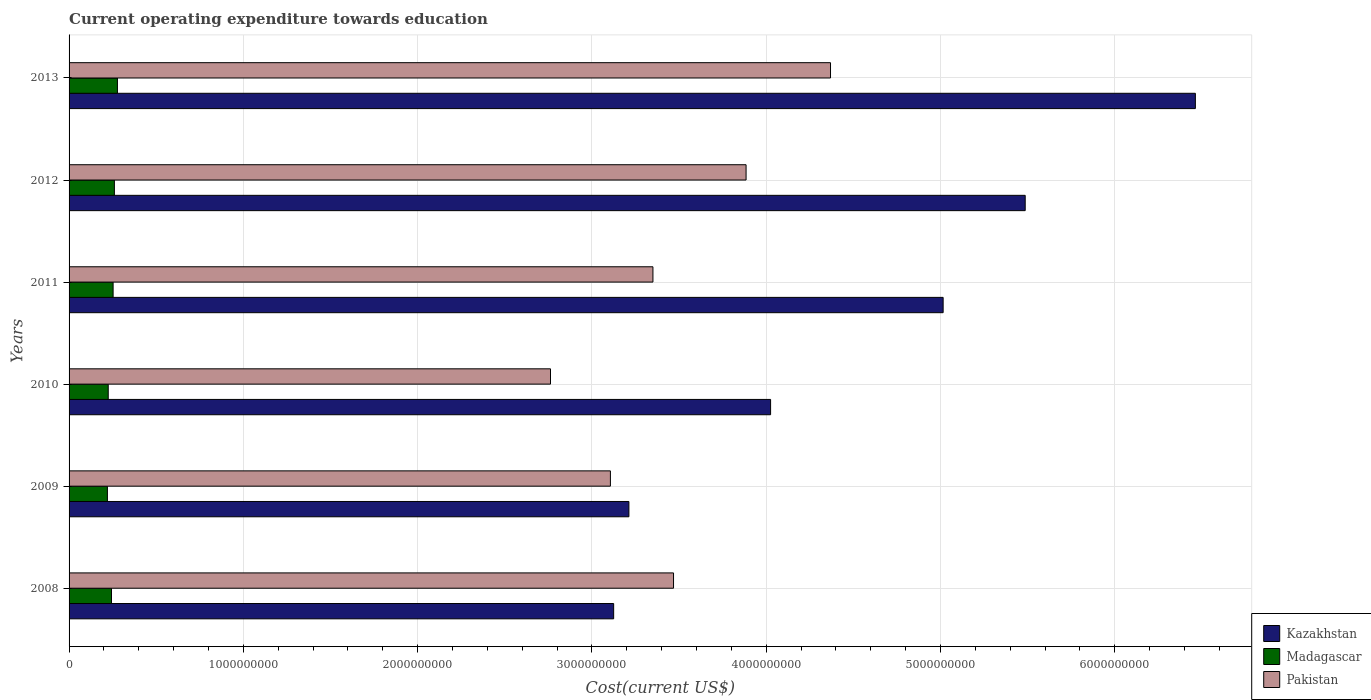How many different coloured bars are there?
Keep it short and to the point. 3. Are the number of bars per tick equal to the number of legend labels?
Make the answer very short. Yes. How many bars are there on the 6th tick from the top?
Ensure brevity in your answer.  3. How many bars are there on the 6th tick from the bottom?
Your response must be concise. 3. What is the label of the 5th group of bars from the top?
Make the answer very short. 2009. In how many cases, is the number of bars for a given year not equal to the number of legend labels?
Provide a succinct answer. 0. What is the expenditure towards education in Madagascar in 2011?
Your answer should be compact. 2.53e+08. Across all years, what is the maximum expenditure towards education in Madagascar?
Give a very brief answer. 2.78e+08. Across all years, what is the minimum expenditure towards education in Pakistan?
Keep it short and to the point. 2.76e+09. What is the total expenditure towards education in Madagascar in the graph?
Provide a succinct answer. 1.48e+09. What is the difference between the expenditure towards education in Kazakhstan in 2008 and that in 2010?
Make the answer very short. -9.00e+08. What is the difference between the expenditure towards education in Madagascar in 2011 and the expenditure towards education in Kazakhstan in 2013?
Provide a succinct answer. -6.21e+09. What is the average expenditure towards education in Kazakhstan per year?
Ensure brevity in your answer.  4.55e+09. In the year 2012, what is the difference between the expenditure towards education in Madagascar and expenditure towards education in Pakistan?
Ensure brevity in your answer.  -3.62e+09. In how many years, is the expenditure towards education in Pakistan greater than 1200000000 US$?
Give a very brief answer. 6. What is the ratio of the expenditure towards education in Kazakhstan in 2008 to that in 2011?
Offer a terse response. 0.62. Is the difference between the expenditure towards education in Madagascar in 2008 and 2013 greater than the difference between the expenditure towards education in Pakistan in 2008 and 2013?
Your response must be concise. Yes. What is the difference between the highest and the second highest expenditure towards education in Kazakhstan?
Keep it short and to the point. 9.76e+08. What is the difference between the highest and the lowest expenditure towards education in Kazakhstan?
Make the answer very short. 3.34e+09. In how many years, is the expenditure towards education in Pakistan greater than the average expenditure towards education in Pakistan taken over all years?
Provide a short and direct response. 2. Is the sum of the expenditure towards education in Kazakhstan in 2011 and 2012 greater than the maximum expenditure towards education in Pakistan across all years?
Make the answer very short. Yes. What does the 2nd bar from the bottom in 2010 represents?
Provide a succinct answer. Madagascar. How many bars are there?
Offer a very short reply. 18. How many years are there in the graph?
Your answer should be compact. 6. What is the difference between two consecutive major ticks on the X-axis?
Provide a succinct answer. 1.00e+09. Does the graph contain any zero values?
Give a very brief answer. No. Does the graph contain grids?
Your answer should be very brief. Yes. Where does the legend appear in the graph?
Give a very brief answer. Bottom right. How are the legend labels stacked?
Your answer should be compact. Vertical. What is the title of the graph?
Provide a short and direct response. Current operating expenditure towards education. What is the label or title of the X-axis?
Offer a terse response. Cost(current US$). What is the label or title of the Y-axis?
Make the answer very short. Years. What is the Cost(current US$) in Kazakhstan in 2008?
Your answer should be compact. 3.12e+09. What is the Cost(current US$) in Madagascar in 2008?
Your answer should be very brief. 2.43e+08. What is the Cost(current US$) of Pakistan in 2008?
Your answer should be compact. 3.47e+09. What is the Cost(current US$) in Kazakhstan in 2009?
Your answer should be very brief. 3.21e+09. What is the Cost(current US$) in Madagascar in 2009?
Your response must be concise. 2.20e+08. What is the Cost(current US$) in Pakistan in 2009?
Ensure brevity in your answer.  3.11e+09. What is the Cost(current US$) of Kazakhstan in 2010?
Keep it short and to the point. 4.03e+09. What is the Cost(current US$) in Madagascar in 2010?
Ensure brevity in your answer.  2.25e+08. What is the Cost(current US$) in Pakistan in 2010?
Provide a succinct answer. 2.76e+09. What is the Cost(current US$) in Kazakhstan in 2011?
Your answer should be compact. 5.02e+09. What is the Cost(current US$) in Madagascar in 2011?
Make the answer very short. 2.53e+08. What is the Cost(current US$) in Pakistan in 2011?
Ensure brevity in your answer.  3.35e+09. What is the Cost(current US$) of Kazakhstan in 2012?
Ensure brevity in your answer.  5.49e+09. What is the Cost(current US$) in Madagascar in 2012?
Offer a very short reply. 2.60e+08. What is the Cost(current US$) of Pakistan in 2012?
Offer a very short reply. 3.88e+09. What is the Cost(current US$) of Kazakhstan in 2013?
Provide a succinct answer. 6.46e+09. What is the Cost(current US$) of Madagascar in 2013?
Keep it short and to the point. 2.78e+08. What is the Cost(current US$) in Pakistan in 2013?
Your answer should be compact. 4.37e+09. Across all years, what is the maximum Cost(current US$) in Kazakhstan?
Offer a terse response. 6.46e+09. Across all years, what is the maximum Cost(current US$) in Madagascar?
Ensure brevity in your answer.  2.78e+08. Across all years, what is the maximum Cost(current US$) in Pakistan?
Your answer should be very brief. 4.37e+09. Across all years, what is the minimum Cost(current US$) in Kazakhstan?
Give a very brief answer. 3.12e+09. Across all years, what is the minimum Cost(current US$) of Madagascar?
Offer a very short reply. 2.20e+08. Across all years, what is the minimum Cost(current US$) of Pakistan?
Your answer should be compact. 2.76e+09. What is the total Cost(current US$) in Kazakhstan in the graph?
Ensure brevity in your answer.  2.73e+1. What is the total Cost(current US$) in Madagascar in the graph?
Your answer should be very brief. 1.48e+09. What is the total Cost(current US$) in Pakistan in the graph?
Your answer should be compact. 2.09e+1. What is the difference between the Cost(current US$) of Kazakhstan in 2008 and that in 2009?
Ensure brevity in your answer.  -8.75e+07. What is the difference between the Cost(current US$) in Madagascar in 2008 and that in 2009?
Your response must be concise. 2.35e+07. What is the difference between the Cost(current US$) of Pakistan in 2008 and that in 2009?
Make the answer very short. 3.62e+08. What is the difference between the Cost(current US$) of Kazakhstan in 2008 and that in 2010?
Provide a short and direct response. -9.00e+08. What is the difference between the Cost(current US$) in Madagascar in 2008 and that in 2010?
Ensure brevity in your answer.  1.87e+07. What is the difference between the Cost(current US$) of Pakistan in 2008 and that in 2010?
Provide a succinct answer. 7.06e+08. What is the difference between the Cost(current US$) of Kazakhstan in 2008 and that in 2011?
Keep it short and to the point. -1.89e+09. What is the difference between the Cost(current US$) in Madagascar in 2008 and that in 2011?
Provide a short and direct response. -9.28e+06. What is the difference between the Cost(current US$) of Pakistan in 2008 and that in 2011?
Provide a succinct answer. 1.18e+08. What is the difference between the Cost(current US$) of Kazakhstan in 2008 and that in 2012?
Give a very brief answer. -2.36e+09. What is the difference between the Cost(current US$) in Madagascar in 2008 and that in 2012?
Your answer should be very brief. -1.66e+07. What is the difference between the Cost(current US$) in Pakistan in 2008 and that in 2012?
Your answer should be very brief. -4.16e+08. What is the difference between the Cost(current US$) in Kazakhstan in 2008 and that in 2013?
Provide a short and direct response. -3.34e+09. What is the difference between the Cost(current US$) of Madagascar in 2008 and that in 2013?
Keep it short and to the point. -3.41e+07. What is the difference between the Cost(current US$) in Pakistan in 2008 and that in 2013?
Ensure brevity in your answer.  -9.01e+08. What is the difference between the Cost(current US$) in Kazakhstan in 2009 and that in 2010?
Ensure brevity in your answer.  -8.13e+08. What is the difference between the Cost(current US$) in Madagascar in 2009 and that in 2010?
Provide a succinct answer. -4.79e+06. What is the difference between the Cost(current US$) in Pakistan in 2009 and that in 2010?
Provide a succinct answer. 3.44e+08. What is the difference between the Cost(current US$) of Kazakhstan in 2009 and that in 2011?
Ensure brevity in your answer.  -1.80e+09. What is the difference between the Cost(current US$) of Madagascar in 2009 and that in 2011?
Provide a succinct answer. -3.28e+07. What is the difference between the Cost(current US$) in Pakistan in 2009 and that in 2011?
Your answer should be compact. -2.44e+08. What is the difference between the Cost(current US$) in Kazakhstan in 2009 and that in 2012?
Your answer should be compact. -2.27e+09. What is the difference between the Cost(current US$) of Madagascar in 2009 and that in 2012?
Your answer should be very brief. -4.01e+07. What is the difference between the Cost(current US$) in Pakistan in 2009 and that in 2012?
Provide a succinct answer. -7.79e+08. What is the difference between the Cost(current US$) of Kazakhstan in 2009 and that in 2013?
Ensure brevity in your answer.  -3.25e+09. What is the difference between the Cost(current US$) in Madagascar in 2009 and that in 2013?
Your answer should be compact. -5.76e+07. What is the difference between the Cost(current US$) of Pakistan in 2009 and that in 2013?
Give a very brief answer. -1.26e+09. What is the difference between the Cost(current US$) of Kazakhstan in 2010 and that in 2011?
Provide a succinct answer. -9.90e+08. What is the difference between the Cost(current US$) in Madagascar in 2010 and that in 2011?
Offer a very short reply. -2.80e+07. What is the difference between the Cost(current US$) in Pakistan in 2010 and that in 2011?
Give a very brief answer. -5.88e+08. What is the difference between the Cost(current US$) in Kazakhstan in 2010 and that in 2012?
Your answer should be very brief. -1.46e+09. What is the difference between the Cost(current US$) in Madagascar in 2010 and that in 2012?
Keep it short and to the point. -3.53e+07. What is the difference between the Cost(current US$) of Pakistan in 2010 and that in 2012?
Offer a terse response. -1.12e+09. What is the difference between the Cost(current US$) in Kazakhstan in 2010 and that in 2013?
Keep it short and to the point. -2.44e+09. What is the difference between the Cost(current US$) of Madagascar in 2010 and that in 2013?
Offer a very short reply. -5.28e+07. What is the difference between the Cost(current US$) in Pakistan in 2010 and that in 2013?
Keep it short and to the point. -1.61e+09. What is the difference between the Cost(current US$) in Kazakhstan in 2011 and that in 2012?
Your answer should be compact. -4.71e+08. What is the difference between the Cost(current US$) in Madagascar in 2011 and that in 2012?
Provide a succinct answer. -7.31e+06. What is the difference between the Cost(current US$) in Pakistan in 2011 and that in 2012?
Make the answer very short. -5.34e+08. What is the difference between the Cost(current US$) of Kazakhstan in 2011 and that in 2013?
Your answer should be compact. -1.45e+09. What is the difference between the Cost(current US$) in Madagascar in 2011 and that in 2013?
Give a very brief answer. -2.48e+07. What is the difference between the Cost(current US$) of Pakistan in 2011 and that in 2013?
Give a very brief answer. -1.02e+09. What is the difference between the Cost(current US$) in Kazakhstan in 2012 and that in 2013?
Ensure brevity in your answer.  -9.76e+08. What is the difference between the Cost(current US$) of Madagascar in 2012 and that in 2013?
Ensure brevity in your answer.  -1.75e+07. What is the difference between the Cost(current US$) of Pakistan in 2012 and that in 2013?
Your answer should be compact. -4.84e+08. What is the difference between the Cost(current US$) of Kazakhstan in 2008 and the Cost(current US$) of Madagascar in 2009?
Keep it short and to the point. 2.90e+09. What is the difference between the Cost(current US$) of Kazakhstan in 2008 and the Cost(current US$) of Pakistan in 2009?
Your answer should be compact. 1.87e+07. What is the difference between the Cost(current US$) of Madagascar in 2008 and the Cost(current US$) of Pakistan in 2009?
Make the answer very short. -2.86e+09. What is the difference between the Cost(current US$) in Kazakhstan in 2008 and the Cost(current US$) in Madagascar in 2010?
Offer a terse response. 2.90e+09. What is the difference between the Cost(current US$) in Kazakhstan in 2008 and the Cost(current US$) in Pakistan in 2010?
Offer a terse response. 3.62e+08. What is the difference between the Cost(current US$) in Madagascar in 2008 and the Cost(current US$) in Pakistan in 2010?
Make the answer very short. -2.52e+09. What is the difference between the Cost(current US$) of Kazakhstan in 2008 and the Cost(current US$) of Madagascar in 2011?
Keep it short and to the point. 2.87e+09. What is the difference between the Cost(current US$) in Kazakhstan in 2008 and the Cost(current US$) in Pakistan in 2011?
Ensure brevity in your answer.  -2.25e+08. What is the difference between the Cost(current US$) of Madagascar in 2008 and the Cost(current US$) of Pakistan in 2011?
Provide a short and direct response. -3.11e+09. What is the difference between the Cost(current US$) in Kazakhstan in 2008 and the Cost(current US$) in Madagascar in 2012?
Offer a terse response. 2.86e+09. What is the difference between the Cost(current US$) in Kazakhstan in 2008 and the Cost(current US$) in Pakistan in 2012?
Provide a short and direct response. -7.60e+08. What is the difference between the Cost(current US$) of Madagascar in 2008 and the Cost(current US$) of Pakistan in 2012?
Provide a short and direct response. -3.64e+09. What is the difference between the Cost(current US$) in Kazakhstan in 2008 and the Cost(current US$) in Madagascar in 2013?
Give a very brief answer. 2.85e+09. What is the difference between the Cost(current US$) in Kazakhstan in 2008 and the Cost(current US$) in Pakistan in 2013?
Your answer should be compact. -1.24e+09. What is the difference between the Cost(current US$) of Madagascar in 2008 and the Cost(current US$) of Pakistan in 2013?
Your answer should be very brief. -4.13e+09. What is the difference between the Cost(current US$) in Kazakhstan in 2009 and the Cost(current US$) in Madagascar in 2010?
Give a very brief answer. 2.99e+09. What is the difference between the Cost(current US$) of Kazakhstan in 2009 and the Cost(current US$) of Pakistan in 2010?
Offer a very short reply. 4.50e+08. What is the difference between the Cost(current US$) in Madagascar in 2009 and the Cost(current US$) in Pakistan in 2010?
Offer a very short reply. -2.54e+09. What is the difference between the Cost(current US$) of Kazakhstan in 2009 and the Cost(current US$) of Madagascar in 2011?
Keep it short and to the point. 2.96e+09. What is the difference between the Cost(current US$) of Kazakhstan in 2009 and the Cost(current US$) of Pakistan in 2011?
Your answer should be very brief. -1.38e+08. What is the difference between the Cost(current US$) of Madagascar in 2009 and the Cost(current US$) of Pakistan in 2011?
Your response must be concise. -3.13e+09. What is the difference between the Cost(current US$) of Kazakhstan in 2009 and the Cost(current US$) of Madagascar in 2012?
Provide a succinct answer. 2.95e+09. What is the difference between the Cost(current US$) in Kazakhstan in 2009 and the Cost(current US$) in Pakistan in 2012?
Provide a short and direct response. -6.72e+08. What is the difference between the Cost(current US$) in Madagascar in 2009 and the Cost(current US$) in Pakistan in 2012?
Offer a terse response. -3.66e+09. What is the difference between the Cost(current US$) in Kazakhstan in 2009 and the Cost(current US$) in Madagascar in 2013?
Offer a very short reply. 2.93e+09. What is the difference between the Cost(current US$) of Kazakhstan in 2009 and the Cost(current US$) of Pakistan in 2013?
Keep it short and to the point. -1.16e+09. What is the difference between the Cost(current US$) of Madagascar in 2009 and the Cost(current US$) of Pakistan in 2013?
Offer a terse response. -4.15e+09. What is the difference between the Cost(current US$) in Kazakhstan in 2010 and the Cost(current US$) in Madagascar in 2011?
Offer a very short reply. 3.77e+09. What is the difference between the Cost(current US$) in Kazakhstan in 2010 and the Cost(current US$) in Pakistan in 2011?
Ensure brevity in your answer.  6.75e+08. What is the difference between the Cost(current US$) of Madagascar in 2010 and the Cost(current US$) of Pakistan in 2011?
Give a very brief answer. -3.13e+09. What is the difference between the Cost(current US$) in Kazakhstan in 2010 and the Cost(current US$) in Madagascar in 2012?
Keep it short and to the point. 3.77e+09. What is the difference between the Cost(current US$) in Kazakhstan in 2010 and the Cost(current US$) in Pakistan in 2012?
Offer a terse response. 1.41e+08. What is the difference between the Cost(current US$) in Madagascar in 2010 and the Cost(current US$) in Pakistan in 2012?
Ensure brevity in your answer.  -3.66e+09. What is the difference between the Cost(current US$) in Kazakhstan in 2010 and the Cost(current US$) in Madagascar in 2013?
Offer a terse response. 3.75e+09. What is the difference between the Cost(current US$) of Kazakhstan in 2010 and the Cost(current US$) of Pakistan in 2013?
Ensure brevity in your answer.  -3.44e+08. What is the difference between the Cost(current US$) in Madagascar in 2010 and the Cost(current US$) in Pakistan in 2013?
Make the answer very short. -4.14e+09. What is the difference between the Cost(current US$) of Kazakhstan in 2011 and the Cost(current US$) of Madagascar in 2012?
Provide a succinct answer. 4.76e+09. What is the difference between the Cost(current US$) of Kazakhstan in 2011 and the Cost(current US$) of Pakistan in 2012?
Your response must be concise. 1.13e+09. What is the difference between the Cost(current US$) of Madagascar in 2011 and the Cost(current US$) of Pakistan in 2012?
Make the answer very short. -3.63e+09. What is the difference between the Cost(current US$) in Kazakhstan in 2011 and the Cost(current US$) in Madagascar in 2013?
Offer a very short reply. 4.74e+09. What is the difference between the Cost(current US$) in Kazakhstan in 2011 and the Cost(current US$) in Pakistan in 2013?
Your answer should be compact. 6.46e+08. What is the difference between the Cost(current US$) in Madagascar in 2011 and the Cost(current US$) in Pakistan in 2013?
Offer a very short reply. -4.12e+09. What is the difference between the Cost(current US$) in Kazakhstan in 2012 and the Cost(current US$) in Madagascar in 2013?
Offer a terse response. 5.21e+09. What is the difference between the Cost(current US$) of Kazakhstan in 2012 and the Cost(current US$) of Pakistan in 2013?
Provide a succinct answer. 1.12e+09. What is the difference between the Cost(current US$) of Madagascar in 2012 and the Cost(current US$) of Pakistan in 2013?
Keep it short and to the point. -4.11e+09. What is the average Cost(current US$) of Kazakhstan per year?
Your response must be concise. 4.55e+09. What is the average Cost(current US$) in Madagascar per year?
Keep it short and to the point. 2.46e+08. What is the average Cost(current US$) in Pakistan per year?
Provide a short and direct response. 3.49e+09. In the year 2008, what is the difference between the Cost(current US$) in Kazakhstan and Cost(current US$) in Madagascar?
Provide a succinct answer. 2.88e+09. In the year 2008, what is the difference between the Cost(current US$) of Kazakhstan and Cost(current US$) of Pakistan?
Ensure brevity in your answer.  -3.43e+08. In the year 2008, what is the difference between the Cost(current US$) in Madagascar and Cost(current US$) in Pakistan?
Keep it short and to the point. -3.22e+09. In the year 2009, what is the difference between the Cost(current US$) of Kazakhstan and Cost(current US$) of Madagascar?
Ensure brevity in your answer.  2.99e+09. In the year 2009, what is the difference between the Cost(current US$) of Kazakhstan and Cost(current US$) of Pakistan?
Offer a very short reply. 1.06e+08. In the year 2009, what is the difference between the Cost(current US$) of Madagascar and Cost(current US$) of Pakistan?
Your answer should be very brief. -2.89e+09. In the year 2010, what is the difference between the Cost(current US$) in Kazakhstan and Cost(current US$) in Madagascar?
Your answer should be compact. 3.80e+09. In the year 2010, what is the difference between the Cost(current US$) in Kazakhstan and Cost(current US$) in Pakistan?
Make the answer very short. 1.26e+09. In the year 2010, what is the difference between the Cost(current US$) in Madagascar and Cost(current US$) in Pakistan?
Your answer should be very brief. -2.54e+09. In the year 2011, what is the difference between the Cost(current US$) of Kazakhstan and Cost(current US$) of Madagascar?
Provide a short and direct response. 4.76e+09. In the year 2011, what is the difference between the Cost(current US$) of Kazakhstan and Cost(current US$) of Pakistan?
Your response must be concise. 1.67e+09. In the year 2011, what is the difference between the Cost(current US$) in Madagascar and Cost(current US$) in Pakistan?
Offer a very short reply. -3.10e+09. In the year 2012, what is the difference between the Cost(current US$) in Kazakhstan and Cost(current US$) in Madagascar?
Your answer should be very brief. 5.23e+09. In the year 2012, what is the difference between the Cost(current US$) of Kazakhstan and Cost(current US$) of Pakistan?
Provide a succinct answer. 1.60e+09. In the year 2012, what is the difference between the Cost(current US$) of Madagascar and Cost(current US$) of Pakistan?
Give a very brief answer. -3.62e+09. In the year 2013, what is the difference between the Cost(current US$) in Kazakhstan and Cost(current US$) in Madagascar?
Your response must be concise. 6.19e+09. In the year 2013, what is the difference between the Cost(current US$) of Kazakhstan and Cost(current US$) of Pakistan?
Provide a short and direct response. 2.09e+09. In the year 2013, what is the difference between the Cost(current US$) in Madagascar and Cost(current US$) in Pakistan?
Your answer should be compact. -4.09e+09. What is the ratio of the Cost(current US$) of Kazakhstan in 2008 to that in 2009?
Keep it short and to the point. 0.97. What is the ratio of the Cost(current US$) of Madagascar in 2008 to that in 2009?
Keep it short and to the point. 1.11. What is the ratio of the Cost(current US$) of Pakistan in 2008 to that in 2009?
Give a very brief answer. 1.12. What is the ratio of the Cost(current US$) in Kazakhstan in 2008 to that in 2010?
Make the answer very short. 0.78. What is the ratio of the Cost(current US$) in Madagascar in 2008 to that in 2010?
Ensure brevity in your answer.  1.08. What is the ratio of the Cost(current US$) of Pakistan in 2008 to that in 2010?
Provide a short and direct response. 1.26. What is the ratio of the Cost(current US$) in Kazakhstan in 2008 to that in 2011?
Your response must be concise. 0.62. What is the ratio of the Cost(current US$) in Madagascar in 2008 to that in 2011?
Your answer should be compact. 0.96. What is the ratio of the Cost(current US$) in Pakistan in 2008 to that in 2011?
Give a very brief answer. 1.04. What is the ratio of the Cost(current US$) of Kazakhstan in 2008 to that in 2012?
Offer a very short reply. 0.57. What is the ratio of the Cost(current US$) of Madagascar in 2008 to that in 2012?
Your response must be concise. 0.94. What is the ratio of the Cost(current US$) in Pakistan in 2008 to that in 2012?
Keep it short and to the point. 0.89. What is the ratio of the Cost(current US$) of Kazakhstan in 2008 to that in 2013?
Your response must be concise. 0.48. What is the ratio of the Cost(current US$) in Madagascar in 2008 to that in 2013?
Offer a very short reply. 0.88. What is the ratio of the Cost(current US$) of Pakistan in 2008 to that in 2013?
Offer a very short reply. 0.79. What is the ratio of the Cost(current US$) in Kazakhstan in 2009 to that in 2010?
Give a very brief answer. 0.8. What is the ratio of the Cost(current US$) in Madagascar in 2009 to that in 2010?
Your answer should be compact. 0.98. What is the ratio of the Cost(current US$) in Pakistan in 2009 to that in 2010?
Your answer should be compact. 1.12. What is the ratio of the Cost(current US$) of Kazakhstan in 2009 to that in 2011?
Your answer should be compact. 0.64. What is the ratio of the Cost(current US$) in Madagascar in 2009 to that in 2011?
Give a very brief answer. 0.87. What is the ratio of the Cost(current US$) of Pakistan in 2009 to that in 2011?
Provide a short and direct response. 0.93. What is the ratio of the Cost(current US$) in Kazakhstan in 2009 to that in 2012?
Ensure brevity in your answer.  0.59. What is the ratio of the Cost(current US$) of Madagascar in 2009 to that in 2012?
Your answer should be very brief. 0.85. What is the ratio of the Cost(current US$) of Pakistan in 2009 to that in 2012?
Make the answer very short. 0.8. What is the ratio of the Cost(current US$) in Kazakhstan in 2009 to that in 2013?
Your answer should be very brief. 0.5. What is the ratio of the Cost(current US$) of Madagascar in 2009 to that in 2013?
Make the answer very short. 0.79. What is the ratio of the Cost(current US$) in Pakistan in 2009 to that in 2013?
Give a very brief answer. 0.71. What is the ratio of the Cost(current US$) in Kazakhstan in 2010 to that in 2011?
Ensure brevity in your answer.  0.8. What is the ratio of the Cost(current US$) of Madagascar in 2010 to that in 2011?
Offer a very short reply. 0.89. What is the ratio of the Cost(current US$) of Pakistan in 2010 to that in 2011?
Give a very brief answer. 0.82. What is the ratio of the Cost(current US$) of Kazakhstan in 2010 to that in 2012?
Give a very brief answer. 0.73. What is the ratio of the Cost(current US$) in Madagascar in 2010 to that in 2012?
Your answer should be compact. 0.86. What is the ratio of the Cost(current US$) of Pakistan in 2010 to that in 2012?
Your answer should be compact. 0.71. What is the ratio of the Cost(current US$) in Kazakhstan in 2010 to that in 2013?
Your response must be concise. 0.62. What is the ratio of the Cost(current US$) in Madagascar in 2010 to that in 2013?
Ensure brevity in your answer.  0.81. What is the ratio of the Cost(current US$) of Pakistan in 2010 to that in 2013?
Keep it short and to the point. 0.63. What is the ratio of the Cost(current US$) of Kazakhstan in 2011 to that in 2012?
Your answer should be compact. 0.91. What is the ratio of the Cost(current US$) of Madagascar in 2011 to that in 2012?
Your answer should be compact. 0.97. What is the ratio of the Cost(current US$) of Pakistan in 2011 to that in 2012?
Offer a terse response. 0.86. What is the ratio of the Cost(current US$) of Kazakhstan in 2011 to that in 2013?
Ensure brevity in your answer.  0.78. What is the ratio of the Cost(current US$) in Madagascar in 2011 to that in 2013?
Provide a short and direct response. 0.91. What is the ratio of the Cost(current US$) of Pakistan in 2011 to that in 2013?
Your response must be concise. 0.77. What is the ratio of the Cost(current US$) of Kazakhstan in 2012 to that in 2013?
Provide a succinct answer. 0.85. What is the ratio of the Cost(current US$) of Madagascar in 2012 to that in 2013?
Keep it short and to the point. 0.94. What is the ratio of the Cost(current US$) of Pakistan in 2012 to that in 2013?
Keep it short and to the point. 0.89. What is the difference between the highest and the second highest Cost(current US$) of Kazakhstan?
Your answer should be compact. 9.76e+08. What is the difference between the highest and the second highest Cost(current US$) in Madagascar?
Your answer should be very brief. 1.75e+07. What is the difference between the highest and the second highest Cost(current US$) in Pakistan?
Your response must be concise. 4.84e+08. What is the difference between the highest and the lowest Cost(current US$) of Kazakhstan?
Keep it short and to the point. 3.34e+09. What is the difference between the highest and the lowest Cost(current US$) in Madagascar?
Offer a terse response. 5.76e+07. What is the difference between the highest and the lowest Cost(current US$) in Pakistan?
Offer a very short reply. 1.61e+09. 